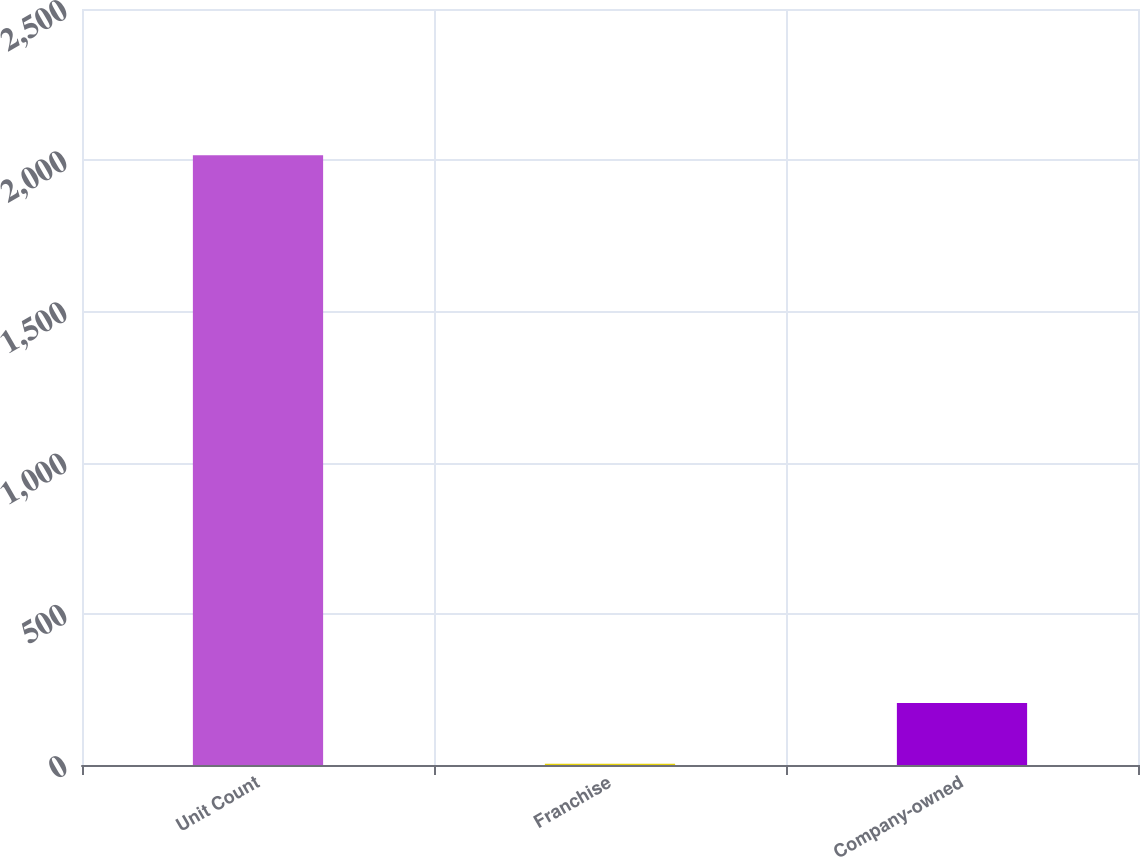<chart> <loc_0><loc_0><loc_500><loc_500><bar_chart><fcel>Unit Count<fcel>Franchise<fcel>Company-owned<nl><fcel>2016<fcel>4<fcel>205.2<nl></chart> 